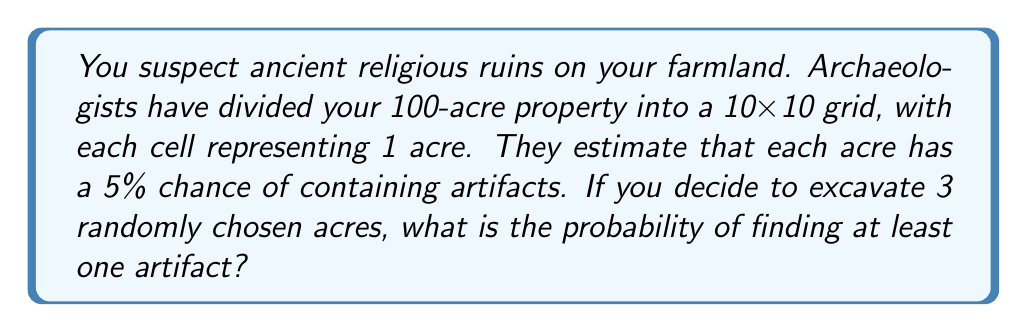Could you help me with this problem? Let's approach this step-by-step:

1) First, we need to calculate the probability of not finding an artifact in a single acre:
   $P(\text{no artifact in one acre}) = 1 - 0.05 = 0.95$ or 95%

2) Now, for three randomly chosen acres, we want the probability of finding at least one artifact. This is equivalent to 1 minus the probability of finding no artifacts in all three acres.

3) The probability of finding no artifacts in all three acres is:
   $P(\text{no artifacts in three acres}) = 0.95 \times 0.95 \times 0.95 = 0.95^3$

4) Therefore, the probability of finding at least one artifact is:
   $$P(\text{at least one artifact}) = 1 - P(\text{no artifacts in three acres})$$
   $$= 1 - 0.95^3$$

5) Let's calculate this:
   $$1 - 0.95^3 = 1 - 0.857375 = 0.142625$$

6) Converting to a percentage:
   $0.142625 \times 100\% = 14.2625\%$

Thus, the probability of finding at least one artifact when excavating 3 randomly chosen acres is approximately 14.26%.
Answer: 14.26% 